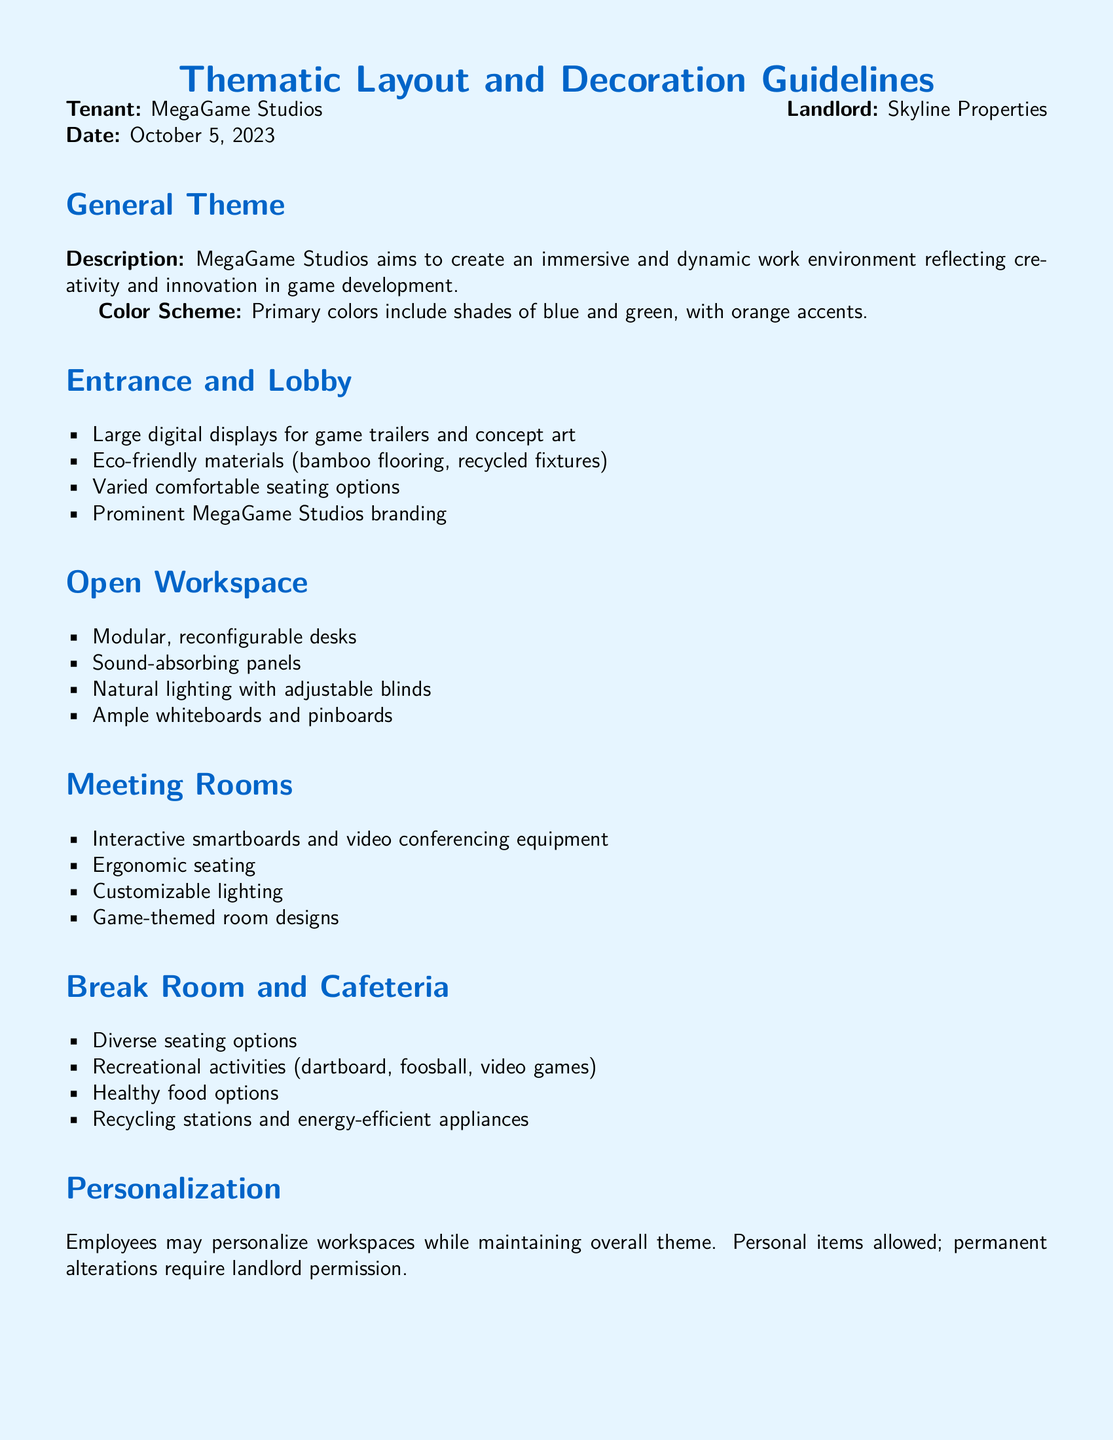What is the name of the tenant? The tenant is identified in the document as MegaGame Studios.
Answer: MegaGame Studios What is the primary color scheme? The document specifies that the primary colors include shades of blue and green, with orange accents.
Answer: Blue, green, orange What kind of flooring is mentioned for the entrance and lobby? The guidelines state that eco-friendly materials should be used, specifically mentioning bamboo flooring.
Answer: Bamboo flooring Who is responsible for daily upkeep? The document outlines the responsibilities for maintenance, indicating that the tenant is responsible for daily upkeep.
Answer: Tenant What type of seating is mentioned for the meeting rooms? The document mentions ergonomic seating as a requirement for the meeting rooms.
Answer: Ergonomic seating What kind of materials should be used in the break room? The break room guidelines include the use of recycling stations and energy-efficient appliances as part of its thematic elements.
Answer: Recycling stations, energy-efficient appliances What are employees allowed to do with their workspaces? The document states that employees may personalize their workspaces while maintaining the overall theme.
Answer: Personalize workspaces How many types of displays are recommended for the entrance? The guidelines suggest the use of large digital displays, indicating a singular type of display format for the entrance and lobby area.
Answer: One type of display What is one feature of the open workspace? The open workspace is characterized by modular, reconfigurable desks according to the guidelines.
Answer: Modular desks 